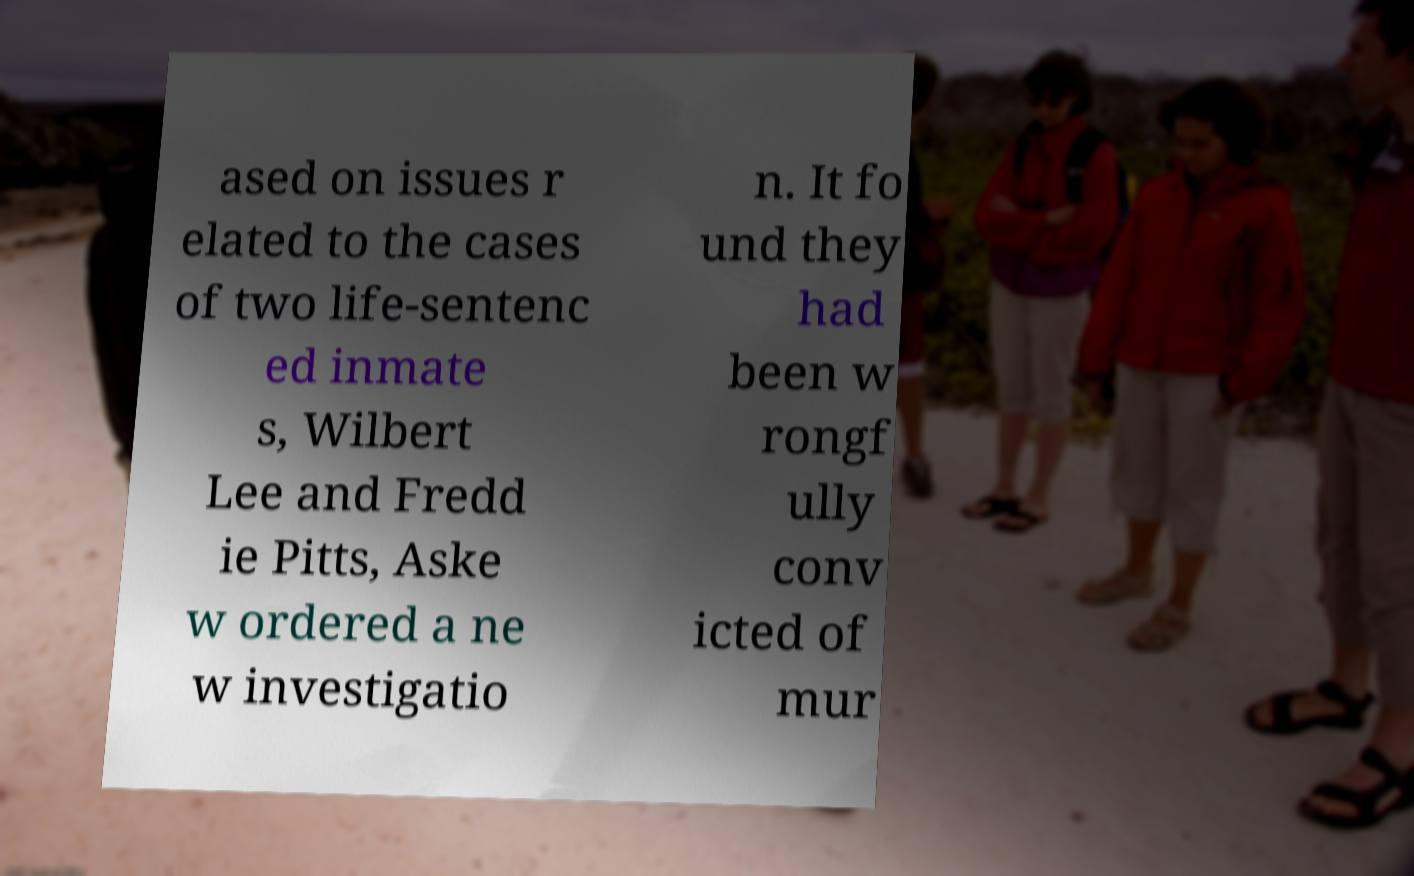Please read and relay the text visible in this image. What does it say? ased on issues r elated to the cases of two life-sentenc ed inmate s, Wilbert Lee and Fredd ie Pitts, Aske w ordered a ne w investigatio n. It fo und they had been w rongf ully conv icted of mur 